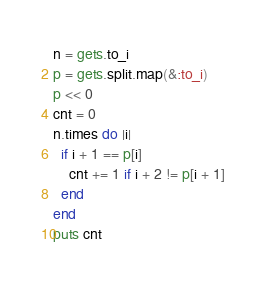Convert code to text. <code><loc_0><loc_0><loc_500><loc_500><_Ruby_>n = gets.to_i
p = gets.split.map(&:to_i)
p << 0
cnt = 0
n.times do |i|
  if i + 1 == p[i]
    cnt += 1 if i + 2 != p[i + 1]
  end
end
puts cnt</code> 